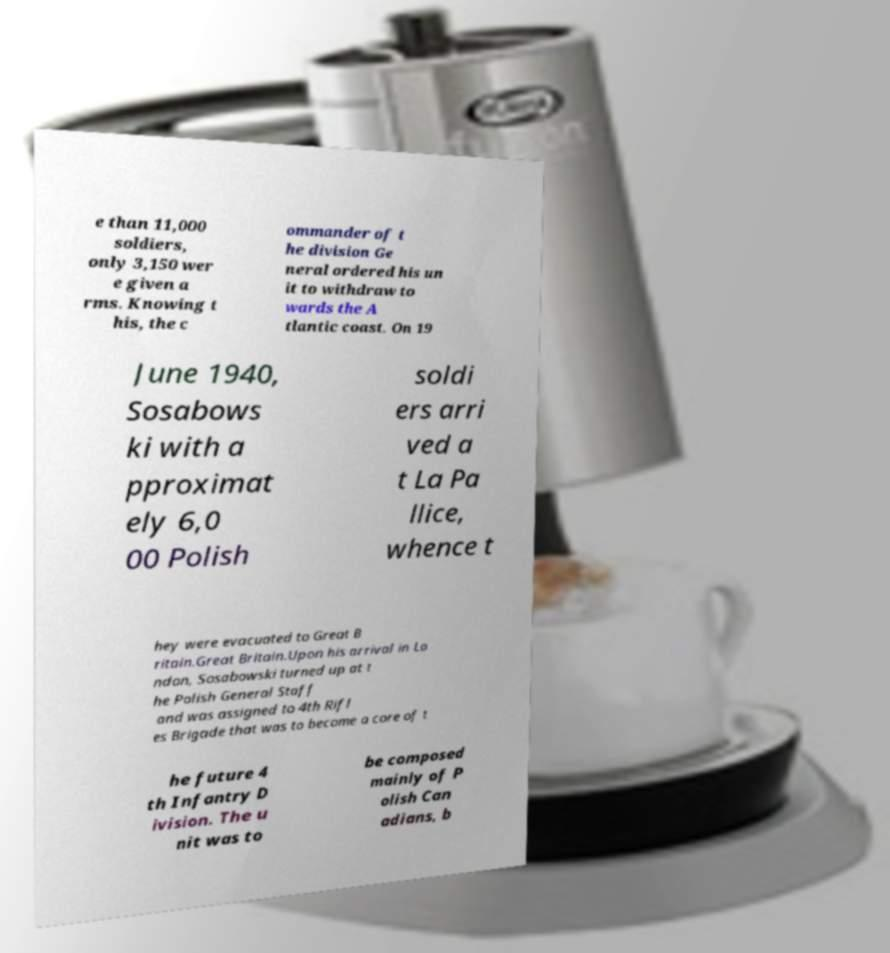I need the written content from this picture converted into text. Can you do that? e than 11,000 soldiers, only 3,150 wer e given a rms. Knowing t his, the c ommander of t he division Ge neral ordered his un it to withdraw to wards the A tlantic coast. On 19 June 1940, Sosabows ki with a pproximat ely 6,0 00 Polish soldi ers arri ved a t La Pa llice, whence t hey were evacuated to Great B ritain.Great Britain.Upon his arrival in Lo ndon, Sosabowski turned up at t he Polish General Staff and was assigned to 4th Rifl es Brigade that was to become a core of t he future 4 th Infantry D ivision. The u nit was to be composed mainly of P olish Can adians, b 